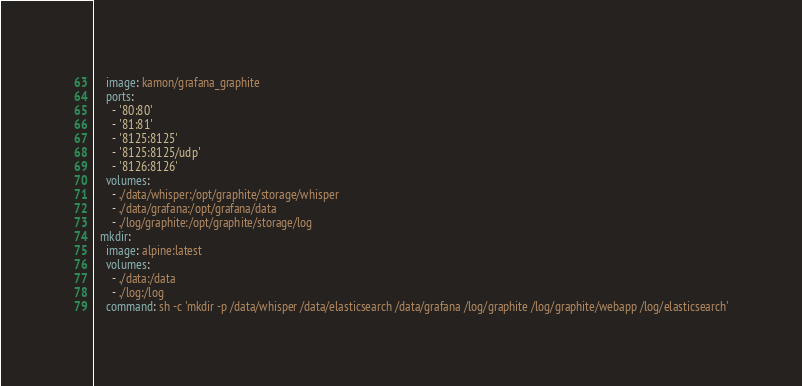Convert code to text. <code><loc_0><loc_0><loc_500><loc_500><_YAML_>    image: kamon/grafana_graphite
    ports:
      - '80:80'
      - '81:81'
      - '8125:8125'
      - '8125:8125/udp'
      - '8126:8126'
    volumes:
      - ./data/whisper:/opt/graphite/storage/whisper
      - ./data/grafana:/opt/grafana/data
      - ./log/graphite:/opt/graphite/storage/log
  mkdir:
    image: alpine:latest
    volumes:
      - ./data:/data
      - ./log:/log
    command: sh -c 'mkdir -p /data/whisper /data/elasticsearch /data/grafana /log/graphite /log/graphite/webapp /log/elasticsearch'
</code> 